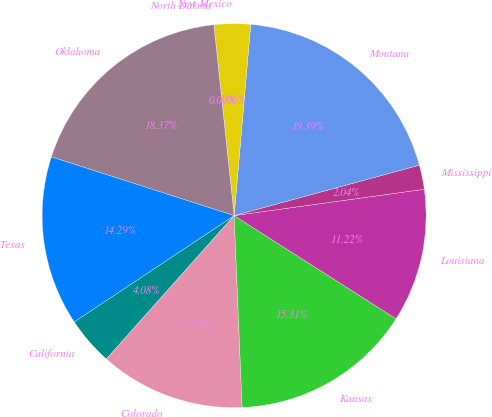Convert chart to OTSL. <chart><loc_0><loc_0><loc_500><loc_500><pie_chart><fcel>California<fcel>Colorado<fcel>Kansas<fcel>Louisiana<fcel>Mississippi<fcel>Montana<fcel>New Mexico<fcel>North Dakota<fcel>Oklahoma<fcel>Texas<nl><fcel>4.08%<fcel>12.24%<fcel>15.3%<fcel>11.22%<fcel>2.04%<fcel>19.38%<fcel>3.06%<fcel>0.0%<fcel>18.36%<fcel>14.28%<nl></chart> 